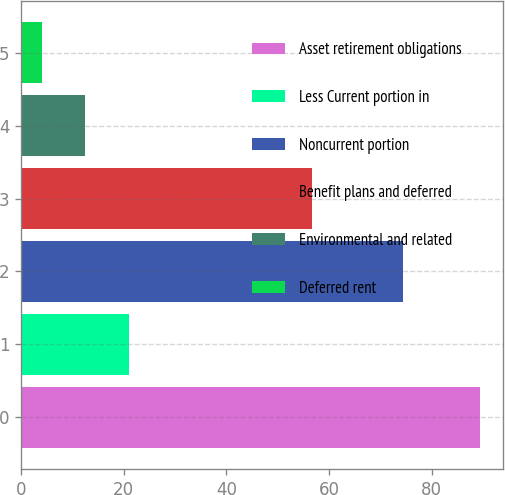<chart> <loc_0><loc_0><loc_500><loc_500><bar_chart><fcel>Asset retirement obligations<fcel>Less Current portion in<fcel>Noncurrent portion<fcel>Benefit plans and deferred<fcel>Environmental and related<fcel>Deferred rent<nl><fcel>89.4<fcel>21.08<fcel>74.4<fcel>56.7<fcel>12.54<fcel>4<nl></chart> 